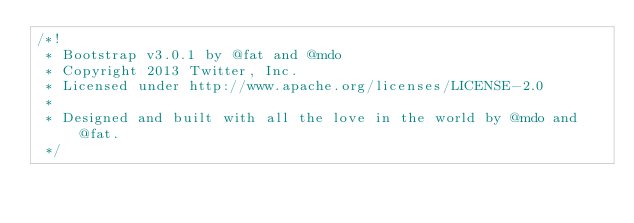<code> <loc_0><loc_0><loc_500><loc_500><_CSS_>/*!
 * Bootstrap v3.0.1 by @fat and @mdo
 * Copyright 2013 Twitter, Inc.
 * Licensed under http://www.apache.org/licenses/LICENSE-2.0
 *
 * Designed and built with all the love in the world by @mdo and @fat.
 */
</code> 